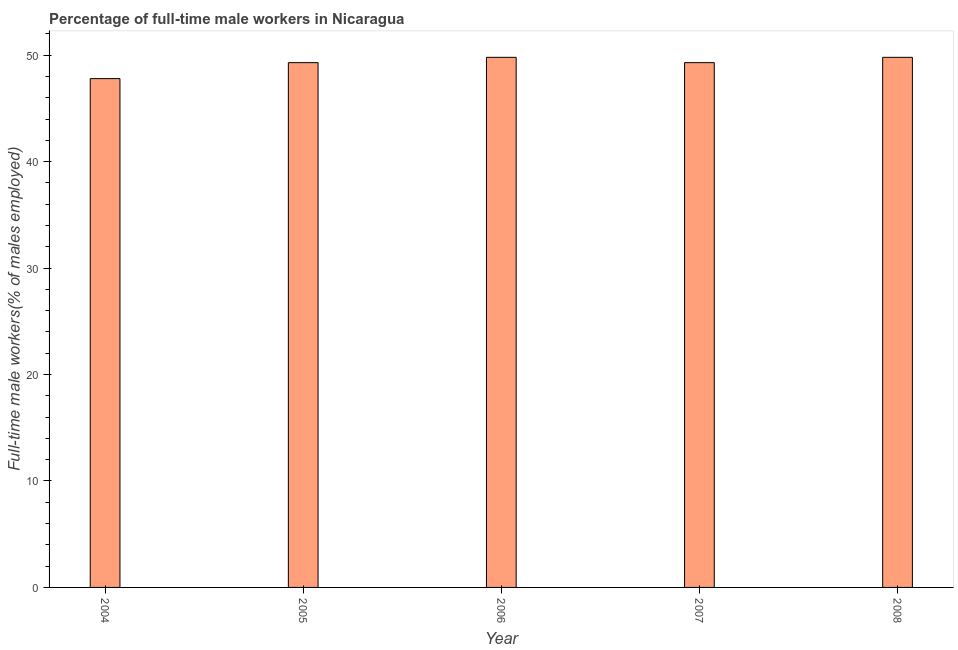Does the graph contain any zero values?
Ensure brevity in your answer.  No. What is the title of the graph?
Provide a succinct answer. Percentage of full-time male workers in Nicaragua. What is the label or title of the Y-axis?
Your response must be concise. Full-time male workers(% of males employed). What is the percentage of full-time male workers in 2008?
Your answer should be compact. 49.8. Across all years, what is the maximum percentage of full-time male workers?
Your answer should be very brief. 49.8. Across all years, what is the minimum percentage of full-time male workers?
Ensure brevity in your answer.  47.8. In which year was the percentage of full-time male workers minimum?
Your response must be concise. 2004. What is the sum of the percentage of full-time male workers?
Your response must be concise. 246. What is the difference between the percentage of full-time male workers in 2006 and 2008?
Keep it short and to the point. 0. What is the average percentage of full-time male workers per year?
Ensure brevity in your answer.  49.2. What is the median percentage of full-time male workers?
Give a very brief answer. 49.3. What is the ratio of the percentage of full-time male workers in 2007 to that in 2008?
Your response must be concise. 0.99. Is the percentage of full-time male workers in 2007 less than that in 2008?
Offer a terse response. Yes. Is the sum of the percentage of full-time male workers in 2004 and 2007 greater than the maximum percentage of full-time male workers across all years?
Your answer should be compact. Yes. How many bars are there?
Give a very brief answer. 5. Are all the bars in the graph horizontal?
Give a very brief answer. No. What is the difference between two consecutive major ticks on the Y-axis?
Offer a terse response. 10. What is the Full-time male workers(% of males employed) of 2004?
Keep it short and to the point. 47.8. What is the Full-time male workers(% of males employed) of 2005?
Offer a very short reply. 49.3. What is the Full-time male workers(% of males employed) in 2006?
Offer a very short reply. 49.8. What is the Full-time male workers(% of males employed) in 2007?
Keep it short and to the point. 49.3. What is the Full-time male workers(% of males employed) in 2008?
Offer a very short reply. 49.8. What is the difference between the Full-time male workers(% of males employed) in 2004 and 2005?
Offer a terse response. -1.5. What is the difference between the Full-time male workers(% of males employed) in 2004 and 2006?
Offer a terse response. -2. What is the difference between the Full-time male workers(% of males employed) in 2005 and 2007?
Make the answer very short. 0. What is the difference between the Full-time male workers(% of males employed) in 2006 and 2008?
Provide a short and direct response. 0. What is the difference between the Full-time male workers(% of males employed) in 2007 and 2008?
Provide a succinct answer. -0.5. What is the ratio of the Full-time male workers(% of males employed) in 2004 to that in 2005?
Ensure brevity in your answer.  0.97. What is the ratio of the Full-time male workers(% of males employed) in 2004 to that in 2008?
Make the answer very short. 0.96. What is the ratio of the Full-time male workers(% of males employed) in 2005 to that in 2008?
Keep it short and to the point. 0.99. What is the ratio of the Full-time male workers(% of males employed) in 2006 to that in 2007?
Offer a very short reply. 1.01. What is the ratio of the Full-time male workers(% of males employed) in 2007 to that in 2008?
Your answer should be very brief. 0.99. 